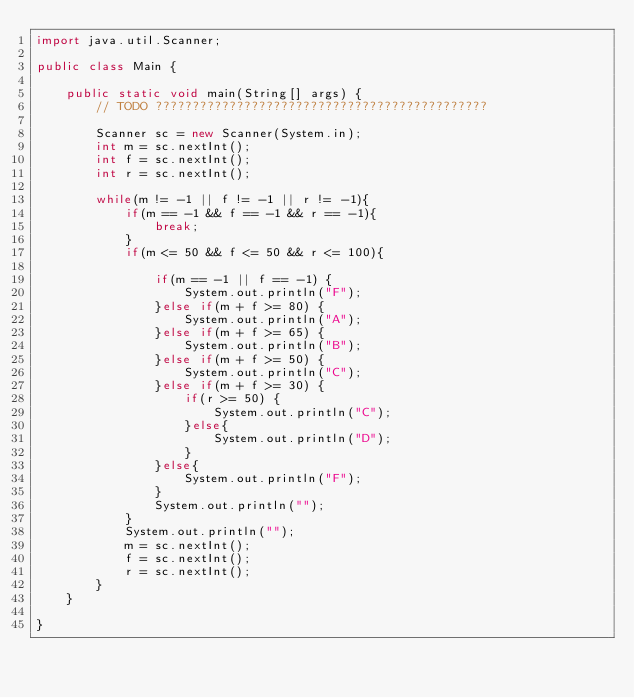Convert code to text. <code><loc_0><loc_0><loc_500><loc_500><_Java_>import java.util.Scanner;

public class Main {

	public static void main(String[] args) {
		// TODO ?????????????????????????????????????????????
		
		Scanner sc = new Scanner(System.in);
		int m = sc.nextInt();
		int f = sc.nextInt();
		int r = sc.nextInt();
		
		while(m != -1 || f != -1 || r != -1){
			if(m == -1 && f == -1 && r == -1){
				break;
			}
			if(m <= 50 && f <= 50 && r <= 100){
				
				if(m == -1 || f == -1) {
					System.out.println("F");
				}else if(m + f >= 80) {
					System.out.println("A");
				}else if(m + f >= 65) {
					System.out.println("B");
				}else if(m + f >= 50) {
					System.out.println("C");
				}else if(m + f >= 30) {
					if(r >= 50) {
						System.out.println("C");
					}else{
						System.out.println("D");
					}
				}else{
					System.out.println("F");
				}
				System.out.println("");
			}
			System.out.println("");
			m = sc.nextInt();
			f = sc.nextInt();
			r = sc.nextInt();
		}
	}

}</code> 